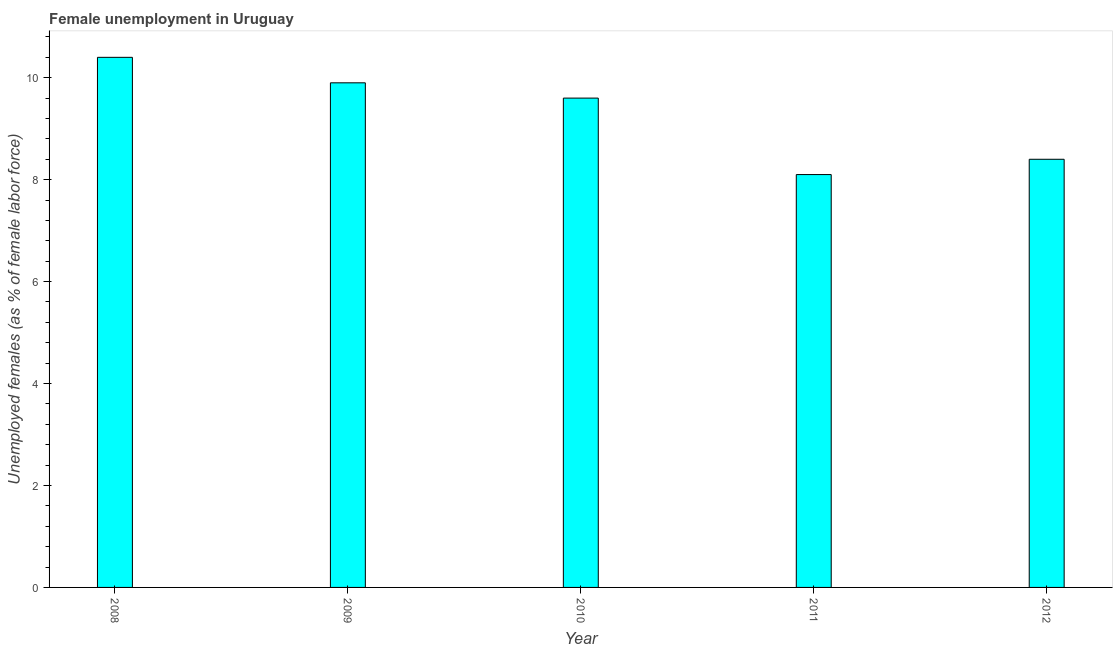Does the graph contain any zero values?
Your answer should be very brief. No. What is the title of the graph?
Ensure brevity in your answer.  Female unemployment in Uruguay. What is the label or title of the Y-axis?
Keep it short and to the point. Unemployed females (as % of female labor force). What is the unemployed females population in 2011?
Provide a succinct answer. 8.1. Across all years, what is the maximum unemployed females population?
Make the answer very short. 10.4. Across all years, what is the minimum unemployed females population?
Make the answer very short. 8.1. What is the sum of the unemployed females population?
Your answer should be compact. 46.4. What is the average unemployed females population per year?
Provide a succinct answer. 9.28. What is the median unemployed females population?
Your response must be concise. 9.6. What is the ratio of the unemployed females population in 2008 to that in 2011?
Your response must be concise. 1.28. Is the unemployed females population in 2009 less than that in 2011?
Provide a short and direct response. No. Is the difference between the unemployed females population in 2010 and 2011 greater than the difference between any two years?
Your answer should be compact. No. What is the difference between the highest and the lowest unemployed females population?
Keep it short and to the point. 2.3. In how many years, is the unemployed females population greater than the average unemployed females population taken over all years?
Keep it short and to the point. 3. How many years are there in the graph?
Offer a very short reply. 5. What is the difference between two consecutive major ticks on the Y-axis?
Provide a short and direct response. 2. Are the values on the major ticks of Y-axis written in scientific E-notation?
Offer a very short reply. No. What is the Unemployed females (as % of female labor force) in 2008?
Your response must be concise. 10.4. What is the Unemployed females (as % of female labor force) of 2009?
Your answer should be very brief. 9.9. What is the Unemployed females (as % of female labor force) of 2010?
Provide a short and direct response. 9.6. What is the Unemployed females (as % of female labor force) in 2011?
Provide a short and direct response. 8.1. What is the Unemployed females (as % of female labor force) in 2012?
Your answer should be compact. 8.4. What is the difference between the Unemployed females (as % of female labor force) in 2009 and 2011?
Provide a short and direct response. 1.8. What is the difference between the Unemployed females (as % of female labor force) in 2009 and 2012?
Provide a succinct answer. 1.5. What is the difference between the Unemployed females (as % of female labor force) in 2011 and 2012?
Your answer should be very brief. -0.3. What is the ratio of the Unemployed females (as % of female labor force) in 2008 to that in 2009?
Your answer should be compact. 1.05. What is the ratio of the Unemployed females (as % of female labor force) in 2008 to that in 2010?
Ensure brevity in your answer.  1.08. What is the ratio of the Unemployed females (as % of female labor force) in 2008 to that in 2011?
Ensure brevity in your answer.  1.28. What is the ratio of the Unemployed females (as % of female labor force) in 2008 to that in 2012?
Your answer should be very brief. 1.24. What is the ratio of the Unemployed females (as % of female labor force) in 2009 to that in 2010?
Make the answer very short. 1.03. What is the ratio of the Unemployed females (as % of female labor force) in 2009 to that in 2011?
Your answer should be compact. 1.22. What is the ratio of the Unemployed females (as % of female labor force) in 2009 to that in 2012?
Ensure brevity in your answer.  1.18. What is the ratio of the Unemployed females (as % of female labor force) in 2010 to that in 2011?
Your response must be concise. 1.19. What is the ratio of the Unemployed females (as % of female labor force) in 2010 to that in 2012?
Give a very brief answer. 1.14. What is the ratio of the Unemployed females (as % of female labor force) in 2011 to that in 2012?
Offer a very short reply. 0.96. 